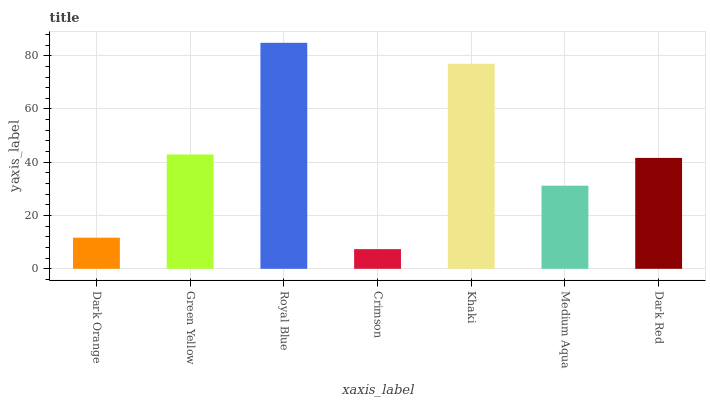Is Crimson the minimum?
Answer yes or no. Yes. Is Royal Blue the maximum?
Answer yes or no. Yes. Is Green Yellow the minimum?
Answer yes or no. No. Is Green Yellow the maximum?
Answer yes or no. No. Is Green Yellow greater than Dark Orange?
Answer yes or no. Yes. Is Dark Orange less than Green Yellow?
Answer yes or no. Yes. Is Dark Orange greater than Green Yellow?
Answer yes or no. No. Is Green Yellow less than Dark Orange?
Answer yes or no. No. Is Dark Red the high median?
Answer yes or no. Yes. Is Dark Red the low median?
Answer yes or no. Yes. Is Dark Orange the high median?
Answer yes or no. No. Is Crimson the low median?
Answer yes or no. No. 